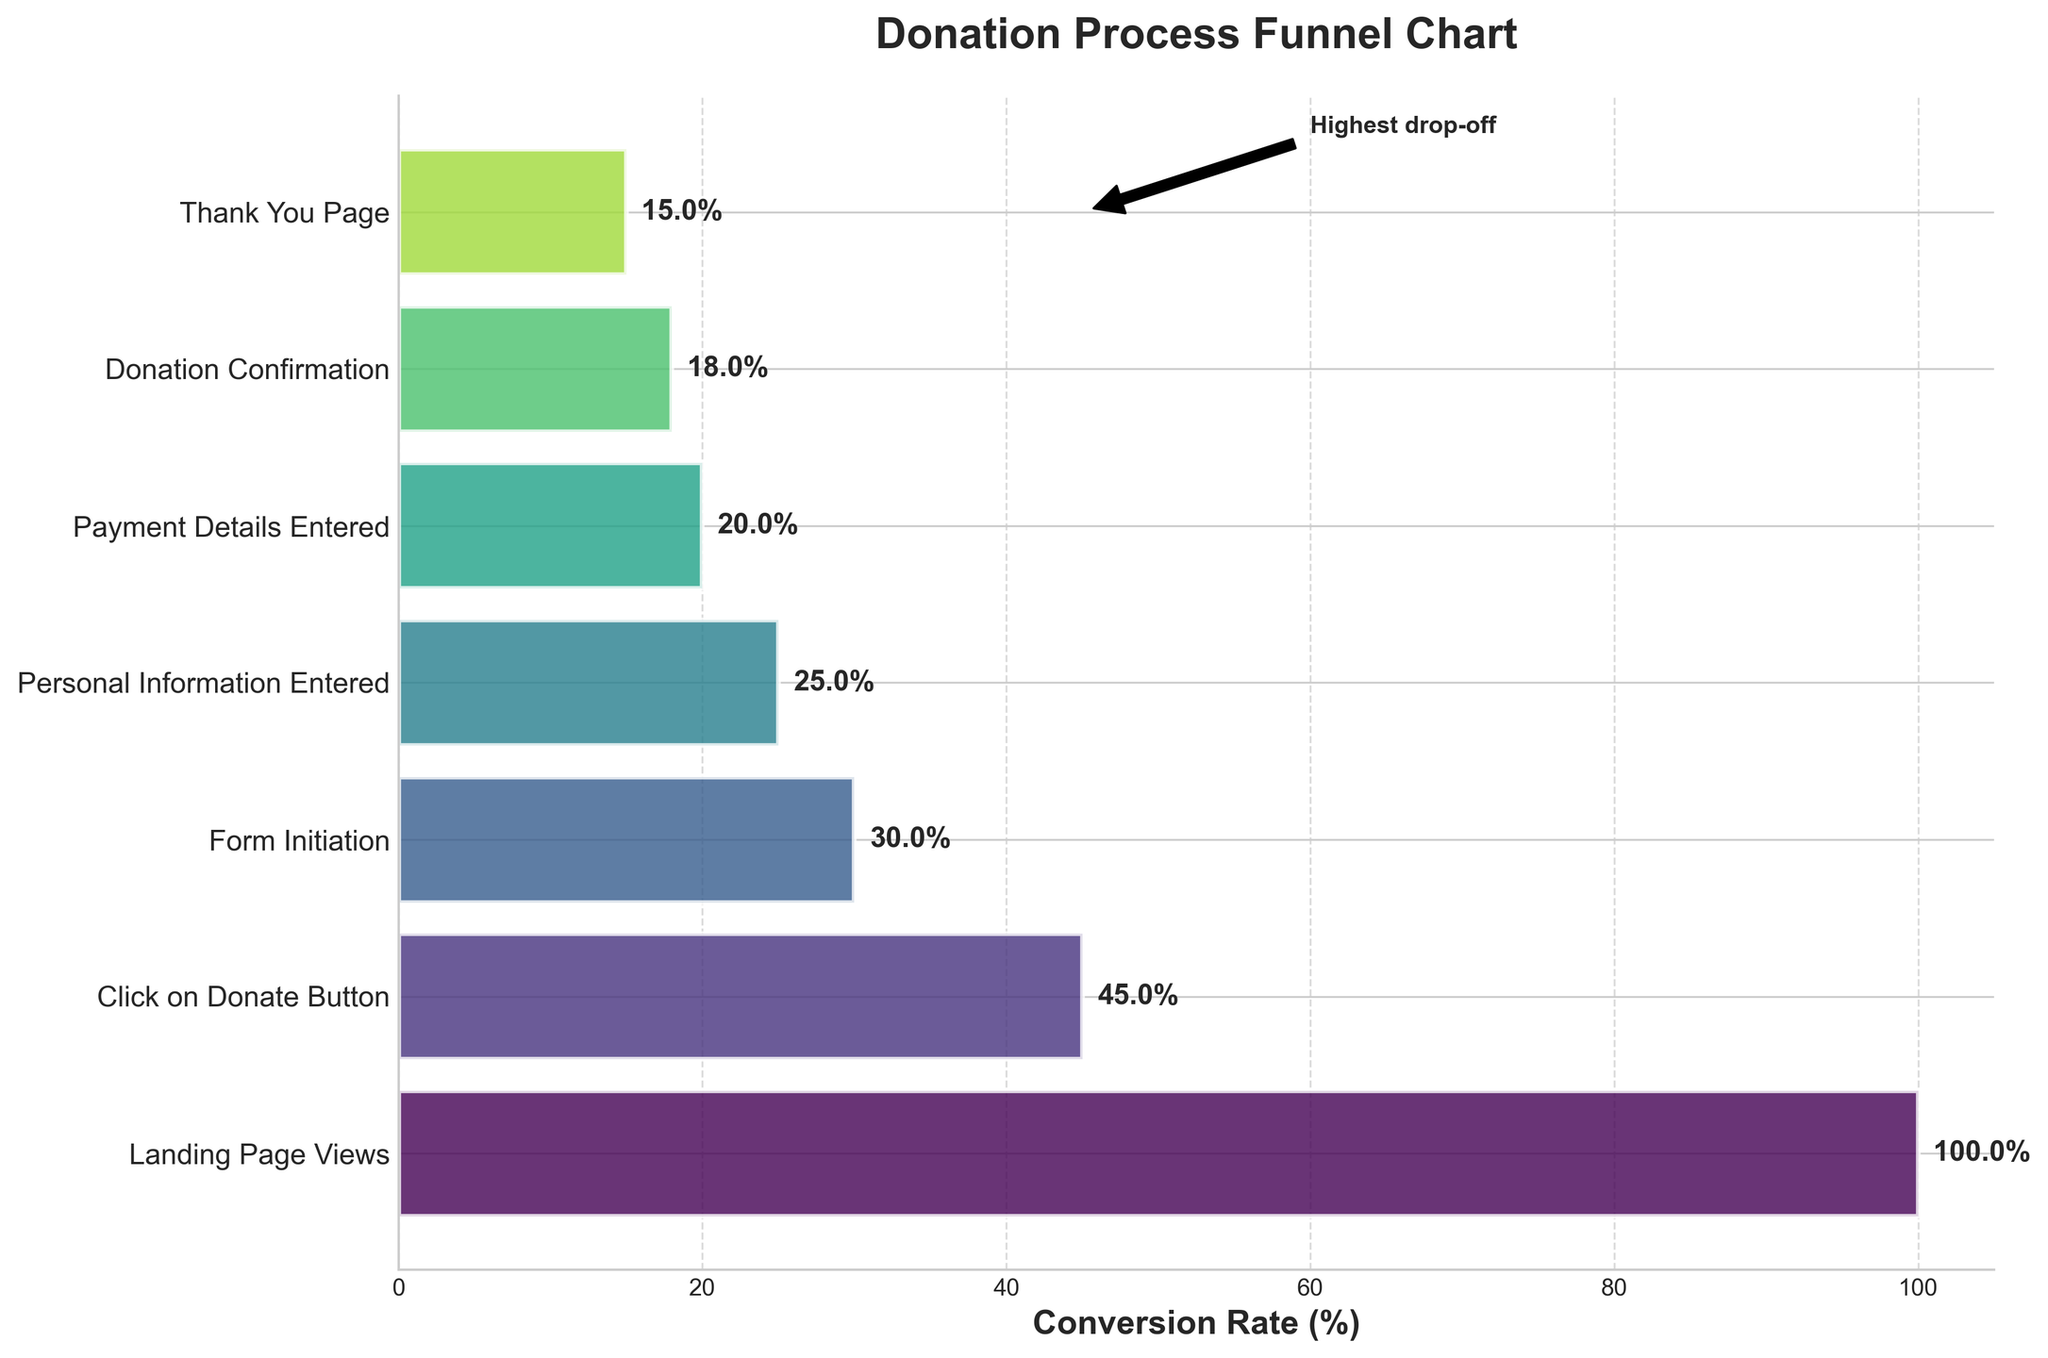What is the overall title of the funnel chart? The overall title of the funnel chart is usually found at the top of the figure in bold text. In this case, the title specifies what the chart is representing.
Answer: Donation Process Funnel Chart What is the conversion rate at the 'Click on Donate Button' stage? You can find the conversion rate for each stage next to the bar on the horizontal funnel chart. The 'Click on Donate Button' stage shows the rate as 45%.
Answer: 45% How many stages are included in the funnel chart? Count the number of y-tick labels or bars on the funnel chart to determine the total stages. The funnel chart includes seven stages.
Answer: 7 Which stage has the highest drop-off rate? The highest drop-off can be inferred by comparing the differences in percentages between consecutive stages. The 'Landing Page Views' to 'Click on Donate Button' stage shows the largest drop from 100% to 45%, which is a 55% drop.
Answer: Click on Donate Button What is the conversion rate difference between 'Form Initiation' and 'Payment Details Entered'? Find the conversion rates for both stages and subtract one from the other. 'Payment Details Entered' is 20% and 'Form Initiation' is 30%. The difference is 30% - 20% = 10%.
Answer: 10% How does the 'Personal Information Entered' stage compare to the 'Thank You Page' stage in terms of conversion rate? Compare the conversion rates of the specified stages. 'Personal Information Entered' has a 25% conversion rate, while the 'Thank You Page' has 15%. 'Personal Information Entered' is higher.
Answer: Personal Information Entered is higher What percentage of users finish the donation process to the 'Donation Confirmation' stage after clicking the 'Donate Button'? The 'Click on Donate Button' stage has a conversion rate of 45%, and the 'Donation Confirmation' stage has a rate of 18%. To find the percentage of users from one stage to another, set up the ratio 18/45 and convert it to a percentage: (18 / 45) * 100% = 40%.
Answer: 40% What stage directly follows 'Personal Information Entered'? Identify the next label in the sequence after 'Personal Information Entered'. The next stage after 'Personal Information Entered' is 'Payment Details Entered'.
Answer: Payment Details Entered Starting from the 'Landing Page Views', what is the overall decrease in conversion rate by the time users reach the 'Thank You Page'? Find the conversion rate at the beginning ('Landing Page Views' at 100%) and the end ('Thank You Page' at 15%), then subtract the final rate from the initial rate. 100% - 15% = 85%.
Answer: 85% 